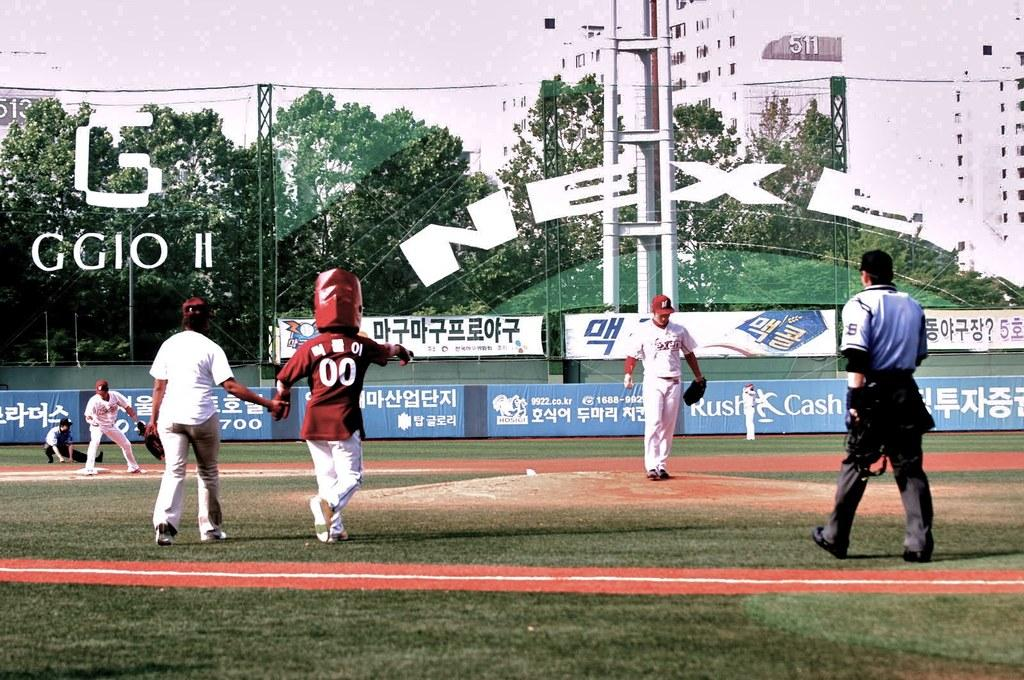<image>
Render a clear and concise summary of the photo. Ball players dot the field in front of various ads, including one for Rush Cash. 